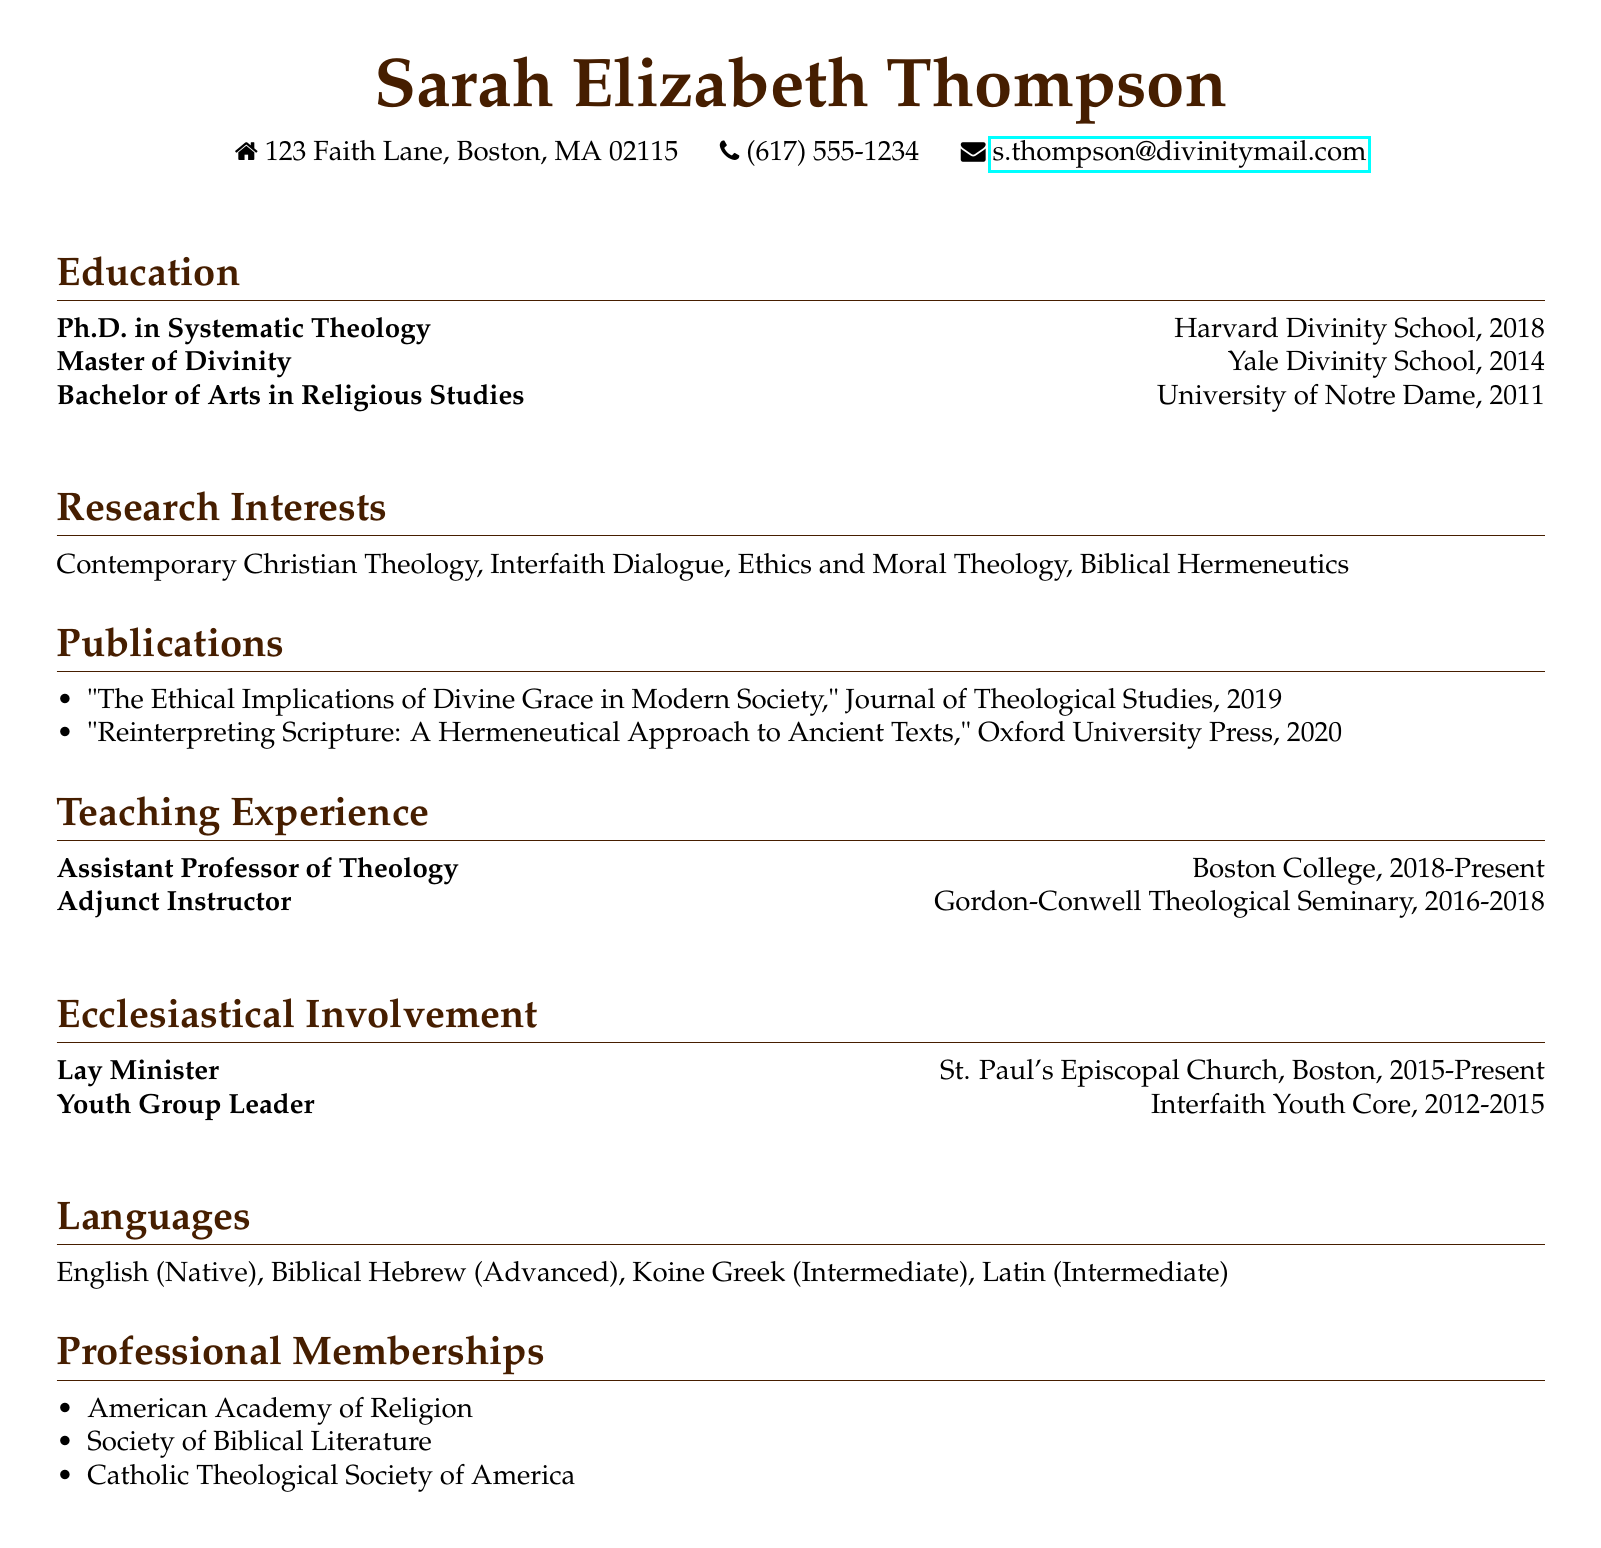What is the name of the individual? The individual's name is provided at the top of the document under personal information.
Answer: Sarah Elizabeth Thompson What degree did Sarah obtain in 2018? The document lists degrees earned, with the degree obtained in 2018 clearly stated.
Answer: Ph.D. in Systematic Theology Where did Sarah obtain her Master of Divinity? The educational background includes the institution where the degree was earned.
Answer: Yale Divinity School What is one of Sarah’s research interests? The research interests section lists several areas of focus, picking any one of them suffices.
Answer: Contemporary Christian Theology How long has Sarah been an Assistant Professor of Theology? The teaching experience section provides the duration of the position, which is crucial for understanding her current role.
Answer: 2018-Present Which church is Sarah a Lay Minister for? The ecclesiastical involvement section specifies her role and the organization she serves.
Answer: St. Paul's Episcopal Church, Boston How many languages can Sarah speak? The languages section outlines her proficiency and indicates the number of languages mentioned.
Answer: Four In which publication did Sarah discuss the ethical implications of divine grace? The publications section identifies a specific article along with the corresponding journal.
Answer: Journal of Theological Studies What is one organization Sarah is a member of? The professional memberships section lists various societies that showcase her affiliations.
Answer: American Academy of Religion 